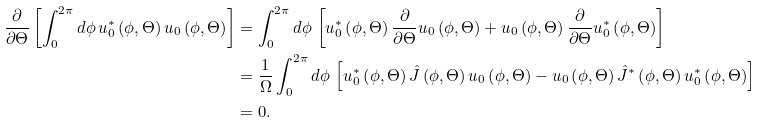<formula> <loc_0><loc_0><loc_500><loc_500>\frac { \partial } { \partial \Theta } \left [ \int _ { 0 } ^ { 2 \pi } d \phi \, u _ { 0 } ^ { \ast } \left ( \phi , \Theta \right ) u _ { 0 } \left ( \phi , \Theta \right ) \right ] & = \int _ { 0 } ^ { 2 \pi } d \phi \, \left [ u _ { 0 } ^ { \ast } \left ( \phi , \Theta \right ) \frac { \partial } { \partial \Theta } u _ { 0 } \left ( \phi , \Theta \right ) + u _ { 0 } \left ( \phi , \Theta \right ) \frac { \partial } { \partial \Theta } u _ { 0 } ^ { \ast } \left ( \phi , \Theta \right ) \right ] \\ & = \frac { 1 } { \Omega } \int _ { 0 } ^ { 2 \pi } d \phi \, \left [ u _ { 0 } ^ { \ast } \left ( \phi , \Theta \right ) \hat { J } \left ( \phi , \Theta \right ) u _ { 0 } \left ( \phi , \Theta \right ) - u _ { 0 } \left ( \phi , \Theta \right ) \hat { J } ^ { \ast } \left ( \phi , \Theta \right ) u _ { 0 } ^ { \ast } \left ( \phi , \Theta \right ) \right ] \\ & = 0 .</formula> 